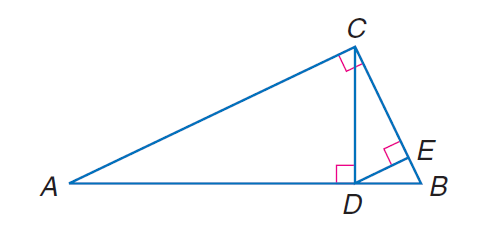Answer the mathemtical geometry problem and directly provide the correct option letter.
Question: Find the exact value of D E, given A D = 12 and B D = 4.
Choices: A: 2 \sqrt { 3 } B: 2 \sqrt { 6 } C: 4 \sqrt { 3 } D: 4 \sqrt { 6 } A 